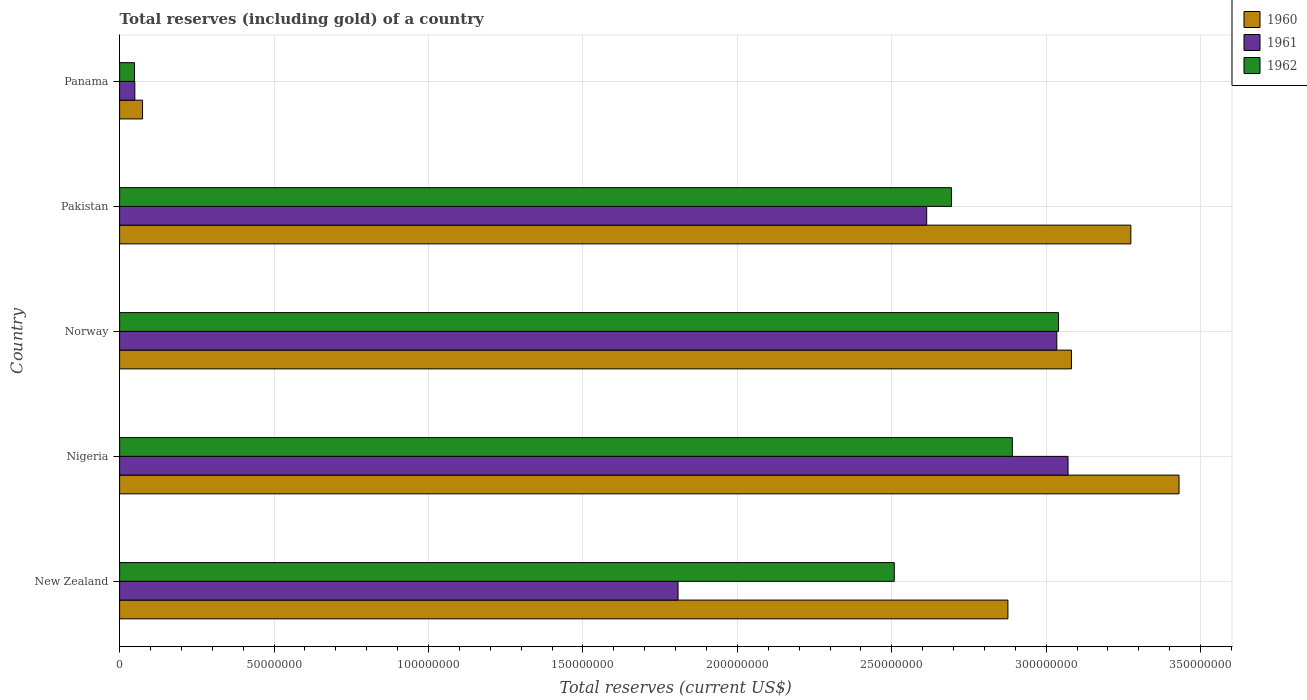How many groups of bars are there?
Your response must be concise. 5. Are the number of bars on each tick of the Y-axis equal?
Your answer should be very brief. Yes. How many bars are there on the 2nd tick from the bottom?
Your answer should be very brief. 3. In how many cases, is the number of bars for a given country not equal to the number of legend labels?
Offer a terse response. 0. What is the total reserves (including gold) in 1961 in Pakistan?
Your answer should be very brief. 2.61e+08. Across all countries, what is the maximum total reserves (including gold) in 1961?
Give a very brief answer. 3.07e+08. Across all countries, what is the minimum total reserves (including gold) in 1960?
Your answer should be very brief. 7.43e+06. In which country was the total reserves (including gold) in 1961 maximum?
Keep it short and to the point. Nigeria. In which country was the total reserves (including gold) in 1960 minimum?
Your answer should be compact. Panama. What is the total total reserves (including gold) in 1962 in the graph?
Provide a succinct answer. 1.12e+09. What is the difference between the total reserves (including gold) in 1961 in Nigeria and that in Pakistan?
Keep it short and to the point. 4.58e+07. What is the difference between the total reserves (including gold) in 1961 in Panama and the total reserves (including gold) in 1962 in Pakistan?
Offer a very short reply. -2.64e+08. What is the average total reserves (including gold) in 1960 per country?
Ensure brevity in your answer.  2.55e+08. What is the difference between the total reserves (including gold) in 1962 and total reserves (including gold) in 1960 in Pakistan?
Provide a succinct answer. -5.81e+07. In how many countries, is the total reserves (including gold) in 1961 greater than 130000000 US$?
Offer a terse response. 4. What is the ratio of the total reserves (including gold) in 1962 in Pakistan to that in Panama?
Your answer should be very brief. 55.76. Is the total reserves (including gold) in 1962 in Norway less than that in Pakistan?
Ensure brevity in your answer.  No. What is the difference between the highest and the second highest total reserves (including gold) in 1962?
Offer a terse response. 1.50e+07. What is the difference between the highest and the lowest total reserves (including gold) in 1960?
Make the answer very short. 3.36e+08. Is the sum of the total reserves (including gold) in 1962 in Norway and Panama greater than the maximum total reserves (including gold) in 1960 across all countries?
Offer a very short reply. No. How many bars are there?
Ensure brevity in your answer.  15. Are all the bars in the graph horizontal?
Provide a short and direct response. Yes. What is the difference between two consecutive major ticks on the X-axis?
Provide a short and direct response. 5.00e+07. Are the values on the major ticks of X-axis written in scientific E-notation?
Keep it short and to the point. No. Does the graph contain any zero values?
Ensure brevity in your answer.  No. Where does the legend appear in the graph?
Provide a short and direct response. Top right. How many legend labels are there?
Your answer should be compact. 3. What is the title of the graph?
Offer a very short reply. Total reserves (including gold) of a country. Does "1962" appear as one of the legend labels in the graph?
Provide a succinct answer. Yes. What is the label or title of the X-axis?
Offer a terse response. Total reserves (current US$). What is the label or title of the Y-axis?
Make the answer very short. Country. What is the Total reserves (current US$) of 1960 in New Zealand?
Provide a succinct answer. 2.88e+08. What is the Total reserves (current US$) in 1961 in New Zealand?
Your answer should be very brief. 1.81e+08. What is the Total reserves (current US$) of 1962 in New Zealand?
Your answer should be compact. 2.51e+08. What is the Total reserves (current US$) in 1960 in Nigeria?
Ensure brevity in your answer.  3.43e+08. What is the Total reserves (current US$) of 1961 in Nigeria?
Your answer should be compact. 3.07e+08. What is the Total reserves (current US$) in 1962 in Nigeria?
Offer a very short reply. 2.89e+08. What is the Total reserves (current US$) in 1960 in Norway?
Give a very brief answer. 3.08e+08. What is the Total reserves (current US$) in 1961 in Norway?
Your answer should be compact. 3.03e+08. What is the Total reserves (current US$) in 1962 in Norway?
Your answer should be compact. 3.04e+08. What is the Total reserves (current US$) of 1960 in Pakistan?
Make the answer very short. 3.27e+08. What is the Total reserves (current US$) in 1961 in Pakistan?
Provide a short and direct response. 2.61e+08. What is the Total reserves (current US$) of 1962 in Pakistan?
Your answer should be compact. 2.69e+08. What is the Total reserves (current US$) of 1960 in Panama?
Give a very brief answer. 7.43e+06. What is the Total reserves (current US$) in 1961 in Panama?
Keep it short and to the point. 4.93e+06. What is the Total reserves (current US$) in 1962 in Panama?
Offer a terse response. 4.83e+06. Across all countries, what is the maximum Total reserves (current US$) of 1960?
Your response must be concise. 3.43e+08. Across all countries, what is the maximum Total reserves (current US$) of 1961?
Give a very brief answer. 3.07e+08. Across all countries, what is the maximum Total reserves (current US$) of 1962?
Your answer should be very brief. 3.04e+08. Across all countries, what is the minimum Total reserves (current US$) in 1960?
Your response must be concise. 7.43e+06. Across all countries, what is the minimum Total reserves (current US$) of 1961?
Your answer should be very brief. 4.93e+06. Across all countries, what is the minimum Total reserves (current US$) in 1962?
Keep it short and to the point. 4.83e+06. What is the total Total reserves (current US$) in 1960 in the graph?
Your response must be concise. 1.27e+09. What is the total Total reserves (current US$) in 1961 in the graph?
Your response must be concise. 1.06e+09. What is the total Total reserves (current US$) in 1962 in the graph?
Keep it short and to the point. 1.12e+09. What is the difference between the Total reserves (current US$) in 1960 in New Zealand and that in Nigeria?
Ensure brevity in your answer.  -5.54e+07. What is the difference between the Total reserves (current US$) in 1961 in New Zealand and that in Nigeria?
Make the answer very short. -1.26e+08. What is the difference between the Total reserves (current US$) of 1962 in New Zealand and that in Nigeria?
Give a very brief answer. -3.82e+07. What is the difference between the Total reserves (current US$) of 1960 in New Zealand and that in Norway?
Offer a very short reply. -2.06e+07. What is the difference between the Total reserves (current US$) in 1961 in New Zealand and that in Norway?
Your answer should be very brief. -1.23e+08. What is the difference between the Total reserves (current US$) of 1962 in New Zealand and that in Norway?
Provide a short and direct response. -5.32e+07. What is the difference between the Total reserves (current US$) of 1960 in New Zealand and that in Pakistan?
Offer a terse response. -3.98e+07. What is the difference between the Total reserves (current US$) in 1961 in New Zealand and that in Pakistan?
Provide a short and direct response. -8.05e+07. What is the difference between the Total reserves (current US$) of 1962 in New Zealand and that in Pakistan?
Make the answer very short. -1.85e+07. What is the difference between the Total reserves (current US$) in 1960 in New Zealand and that in Panama?
Your answer should be compact. 2.80e+08. What is the difference between the Total reserves (current US$) in 1961 in New Zealand and that in Panama?
Provide a succinct answer. 1.76e+08. What is the difference between the Total reserves (current US$) of 1962 in New Zealand and that in Panama?
Offer a very short reply. 2.46e+08. What is the difference between the Total reserves (current US$) of 1960 in Nigeria and that in Norway?
Keep it short and to the point. 3.48e+07. What is the difference between the Total reserves (current US$) of 1961 in Nigeria and that in Norway?
Ensure brevity in your answer.  3.64e+06. What is the difference between the Total reserves (current US$) in 1962 in Nigeria and that in Norway?
Ensure brevity in your answer.  -1.50e+07. What is the difference between the Total reserves (current US$) of 1960 in Nigeria and that in Pakistan?
Your answer should be compact. 1.56e+07. What is the difference between the Total reserves (current US$) in 1961 in Nigeria and that in Pakistan?
Offer a very short reply. 4.58e+07. What is the difference between the Total reserves (current US$) in 1962 in Nigeria and that in Pakistan?
Your response must be concise. 1.97e+07. What is the difference between the Total reserves (current US$) in 1960 in Nigeria and that in Panama?
Your response must be concise. 3.36e+08. What is the difference between the Total reserves (current US$) of 1961 in Nigeria and that in Panama?
Provide a short and direct response. 3.02e+08. What is the difference between the Total reserves (current US$) of 1962 in Nigeria and that in Panama?
Your response must be concise. 2.84e+08. What is the difference between the Total reserves (current US$) of 1960 in Norway and that in Pakistan?
Keep it short and to the point. -1.92e+07. What is the difference between the Total reserves (current US$) in 1961 in Norway and that in Pakistan?
Keep it short and to the point. 4.21e+07. What is the difference between the Total reserves (current US$) in 1962 in Norway and that in Pakistan?
Offer a terse response. 3.47e+07. What is the difference between the Total reserves (current US$) of 1960 in Norway and that in Panama?
Ensure brevity in your answer.  3.01e+08. What is the difference between the Total reserves (current US$) in 1961 in Norway and that in Panama?
Give a very brief answer. 2.99e+08. What is the difference between the Total reserves (current US$) in 1962 in Norway and that in Panama?
Provide a short and direct response. 2.99e+08. What is the difference between the Total reserves (current US$) in 1960 in Pakistan and that in Panama?
Your answer should be compact. 3.20e+08. What is the difference between the Total reserves (current US$) in 1961 in Pakistan and that in Panama?
Offer a terse response. 2.56e+08. What is the difference between the Total reserves (current US$) in 1962 in Pakistan and that in Panama?
Make the answer very short. 2.64e+08. What is the difference between the Total reserves (current US$) of 1960 in New Zealand and the Total reserves (current US$) of 1961 in Nigeria?
Provide a succinct answer. -1.95e+07. What is the difference between the Total reserves (current US$) in 1960 in New Zealand and the Total reserves (current US$) in 1962 in Nigeria?
Your answer should be very brief. -1.43e+06. What is the difference between the Total reserves (current US$) in 1961 in New Zealand and the Total reserves (current US$) in 1962 in Nigeria?
Make the answer very short. -1.08e+08. What is the difference between the Total reserves (current US$) of 1960 in New Zealand and the Total reserves (current US$) of 1961 in Norway?
Offer a very short reply. -1.58e+07. What is the difference between the Total reserves (current US$) of 1960 in New Zealand and the Total reserves (current US$) of 1962 in Norway?
Your answer should be compact. -1.64e+07. What is the difference between the Total reserves (current US$) of 1961 in New Zealand and the Total reserves (current US$) of 1962 in Norway?
Offer a very short reply. -1.23e+08. What is the difference between the Total reserves (current US$) of 1960 in New Zealand and the Total reserves (current US$) of 1961 in Pakistan?
Provide a short and direct response. 2.63e+07. What is the difference between the Total reserves (current US$) in 1960 in New Zealand and the Total reserves (current US$) in 1962 in Pakistan?
Your response must be concise. 1.83e+07. What is the difference between the Total reserves (current US$) of 1961 in New Zealand and the Total reserves (current US$) of 1962 in Pakistan?
Give a very brief answer. -8.85e+07. What is the difference between the Total reserves (current US$) of 1960 in New Zealand and the Total reserves (current US$) of 1961 in Panama?
Ensure brevity in your answer.  2.83e+08. What is the difference between the Total reserves (current US$) in 1960 in New Zealand and the Total reserves (current US$) in 1962 in Panama?
Provide a succinct answer. 2.83e+08. What is the difference between the Total reserves (current US$) in 1961 in New Zealand and the Total reserves (current US$) in 1962 in Panama?
Your answer should be very brief. 1.76e+08. What is the difference between the Total reserves (current US$) of 1960 in Nigeria and the Total reserves (current US$) of 1961 in Norway?
Offer a terse response. 3.96e+07. What is the difference between the Total reserves (current US$) in 1960 in Nigeria and the Total reserves (current US$) in 1962 in Norway?
Give a very brief answer. 3.90e+07. What is the difference between the Total reserves (current US$) in 1961 in Nigeria and the Total reserves (current US$) in 1962 in Norway?
Keep it short and to the point. 3.09e+06. What is the difference between the Total reserves (current US$) in 1960 in Nigeria and the Total reserves (current US$) in 1961 in Pakistan?
Keep it short and to the point. 8.17e+07. What is the difference between the Total reserves (current US$) in 1960 in Nigeria and the Total reserves (current US$) in 1962 in Pakistan?
Your response must be concise. 7.37e+07. What is the difference between the Total reserves (current US$) of 1961 in Nigeria and the Total reserves (current US$) of 1962 in Pakistan?
Provide a succinct answer. 3.78e+07. What is the difference between the Total reserves (current US$) in 1960 in Nigeria and the Total reserves (current US$) in 1961 in Panama?
Your answer should be compact. 3.38e+08. What is the difference between the Total reserves (current US$) in 1960 in Nigeria and the Total reserves (current US$) in 1962 in Panama?
Offer a terse response. 3.38e+08. What is the difference between the Total reserves (current US$) in 1961 in Nigeria and the Total reserves (current US$) in 1962 in Panama?
Offer a terse response. 3.02e+08. What is the difference between the Total reserves (current US$) of 1960 in Norway and the Total reserves (current US$) of 1961 in Pakistan?
Ensure brevity in your answer.  4.69e+07. What is the difference between the Total reserves (current US$) in 1960 in Norway and the Total reserves (current US$) in 1962 in Pakistan?
Keep it short and to the point. 3.89e+07. What is the difference between the Total reserves (current US$) in 1961 in Norway and the Total reserves (current US$) in 1962 in Pakistan?
Your answer should be very brief. 3.41e+07. What is the difference between the Total reserves (current US$) in 1960 in Norway and the Total reserves (current US$) in 1961 in Panama?
Keep it short and to the point. 3.03e+08. What is the difference between the Total reserves (current US$) of 1960 in Norway and the Total reserves (current US$) of 1962 in Panama?
Your answer should be very brief. 3.03e+08. What is the difference between the Total reserves (current US$) of 1961 in Norway and the Total reserves (current US$) of 1962 in Panama?
Your answer should be very brief. 2.99e+08. What is the difference between the Total reserves (current US$) of 1960 in Pakistan and the Total reserves (current US$) of 1961 in Panama?
Keep it short and to the point. 3.22e+08. What is the difference between the Total reserves (current US$) in 1960 in Pakistan and the Total reserves (current US$) in 1962 in Panama?
Make the answer very short. 3.23e+08. What is the difference between the Total reserves (current US$) in 1961 in Pakistan and the Total reserves (current US$) in 1962 in Panama?
Make the answer very short. 2.56e+08. What is the average Total reserves (current US$) of 1960 per country?
Keep it short and to the point. 2.55e+08. What is the average Total reserves (current US$) of 1961 per country?
Provide a succinct answer. 2.12e+08. What is the average Total reserves (current US$) of 1962 per country?
Your answer should be very brief. 2.24e+08. What is the difference between the Total reserves (current US$) of 1960 and Total reserves (current US$) of 1961 in New Zealand?
Ensure brevity in your answer.  1.07e+08. What is the difference between the Total reserves (current US$) of 1960 and Total reserves (current US$) of 1962 in New Zealand?
Your answer should be very brief. 3.68e+07. What is the difference between the Total reserves (current US$) of 1961 and Total reserves (current US$) of 1962 in New Zealand?
Your response must be concise. -7.00e+07. What is the difference between the Total reserves (current US$) of 1960 and Total reserves (current US$) of 1961 in Nigeria?
Your answer should be compact. 3.59e+07. What is the difference between the Total reserves (current US$) of 1960 and Total reserves (current US$) of 1962 in Nigeria?
Keep it short and to the point. 5.40e+07. What is the difference between the Total reserves (current US$) of 1961 and Total reserves (current US$) of 1962 in Nigeria?
Your response must be concise. 1.80e+07. What is the difference between the Total reserves (current US$) of 1960 and Total reserves (current US$) of 1961 in Norway?
Your response must be concise. 4.75e+06. What is the difference between the Total reserves (current US$) in 1960 and Total reserves (current US$) in 1962 in Norway?
Provide a short and direct response. 4.20e+06. What is the difference between the Total reserves (current US$) in 1961 and Total reserves (current US$) in 1962 in Norway?
Keep it short and to the point. -5.46e+05. What is the difference between the Total reserves (current US$) of 1960 and Total reserves (current US$) of 1961 in Pakistan?
Your answer should be compact. 6.61e+07. What is the difference between the Total reserves (current US$) in 1960 and Total reserves (current US$) in 1962 in Pakistan?
Offer a terse response. 5.81e+07. What is the difference between the Total reserves (current US$) of 1961 and Total reserves (current US$) of 1962 in Pakistan?
Ensure brevity in your answer.  -8.01e+06. What is the difference between the Total reserves (current US$) of 1960 and Total reserves (current US$) of 1961 in Panama?
Ensure brevity in your answer.  2.50e+06. What is the difference between the Total reserves (current US$) in 1960 and Total reserves (current US$) in 1962 in Panama?
Keep it short and to the point. 2.60e+06. What is the difference between the Total reserves (current US$) of 1961 and Total reserves (current US$) of 1962 in Panama?
Ensure brevity in your answer.  1.00e+05. What is the ratio of the Total reserves (current US$) of 1960 in New Zealand to that in Nigeria?
Your answer should be very brief. 0.84. What is the ratio of the Total reserves (current US$) of 1961 in New Zealand to that in Nigeria?
Provide a short and direct response. 0.59. What is the ratio of the Total reserves (current US$) of 1962 in New Zealand to that in Nigeria?
Provide a short and direct response. 0.87. What is the ratio of the Total reserves (current US$) in 1960 in New Zealand to that in Norway?
Offer a very short reply. 0.93. What is the ratio of the Total reserves (current US$) in 1961 in New Zealand to that in Norway?
Your answer should be compact. 0.6. What is the ratio of the Total reserves (current US$) in 1962 in New Zealand to that in Norway?
Provide a succinct answer. 0.83. What is the ratio of the Total reserves (current US$) of 1960 in New Zealand to that in Pakistan?
Provide a short and direct response. 0.88. What is the ratio of the Total reserves (current US$) in 1961 in New Zealand to that in Pakistan?
Give a very brief answer. 0.69. What is the ratio of the Total reserves (current US$) of 1962 in New Zealand to that in Pakistan?
Your response must be concise. 0.93. What is the ratio of the Total reserves (current US$) in 1960 in New Zealand to that in Panama?
Give a very brief answer. 38.71. What is the ratio of the Total reserves (current US$) of 1961 in New Zealand to that in Panama?
Keep it short and to the point. 36.67. What is the ratio of the Total reserves (current US$) of 1962 in New Zealand to that in Panama?
Provide a succinct answer. 51.93. What is the ratio of the Total reserves (current US$) of 1960 in Nigeria to that in Norway?
Give a very brief answer. 1.11. What is the ratio of the Total reserves (current US$) in 1961 in Nigeria to that in Norway?
Your answer should be very brief. 1.01. What is the ratio of the Total reserves (current US$) in 1962 in Nigeria to that in Norway?
Provide a succinct answer. 0.95. What is the ratio of the Total reserves (current US$) of 1960 in Nigeria to that in Pakistan?
Offer a very short reply. 1.05. What is the ratio of the Total reserves (current US$) in 1961 in Nigeria to that in Pakistan?
Ensure brevity in your answer.  1.18. What is the ratio of the Total reserves (current US$) of 1962 in Nigeria to that in Pakistan?
Your answer should be very brief. 1.07. What is the ratio of the Total reserves (current US$) of 1960 in Nigeria to that in Panama?
Make the answer very short. 46.16. What is the ratio of the Total reserves (current US$) in 1961 in Nigeria to that in Panama?
Your answer should be very brief. 62.29. What is the ratio of the Total reserves (current US$) of 1962 in Nigeria to that in Panama?
Provide a short and direct response. 59.84. What is the ratio of the Total reserves (current US$) of 1960 in Norway to that in Pakistan?
Your answer should be compact. 0.94. What is the ratio of the Total reserves (current US$) of 1961 in Norway to that in Pakistan?
Keep it short and to the point. 1.16. What is the ratio of the Total reserves (current US$) of 1962 in Norway to that in Pakistan?
Offer a very short reply. 1.13. What is the ratio of the Total reserves (current US$) in 1960 in Norway to that in Panama?
Your response must be concise. 41.48. What is the ratio of the Total reserves (current US$) in 1961 in Norway to that in Panama?
Ensure brevity in your answer.  61.55. What is the ratio of the Total reserves (current US$) of 1962 in Norway to that in Panama?
Give a very brief answer. 62.94. What is the ratio of the Total reserves (current US$) of 1960 in Pakistan to that in Panama?
Provide a short and direct response. 44.06. What is the ratio of the Total reserves (current US$) in 1961 in Pakistan to that in Panama?
Provide a succinct answer. 53. What is the ratio of the Total reserves (current US$) in 1962 in Pakistan to that in Panama?
Offer a very short reply. 55.76. What is the difference between the highest and the second highest Total reserves (current US$) of 1960?
Offer a very short reply. 1.56e+07. What is the difference between the highest and the second highest Total reserves (current US$) of 1961?
Ensure brevity in your answer.  3.64e+06. What is the difference between the highest and the second highest Total reserves (current US$) of 1962?
Your response must be concise. 1.50e+07. What is the difference between the highest and the lowest Total reserves (current US$) of 1960?
Your answer should be very brief. 3.36e+08. What is the difference between the highest and the lowest Total reserves (current US$) in 1961?
Provide a succinct answer. 3.02e+08. What is the difference between the highest and the lowest Total reserves (current US$) of 1962?
Offer a very short reply. 2.99e+08. 